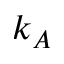Convert formula to latex. <formula><loc_0><loc_0><loc_500><loc_500>k _ { A }</formula> 